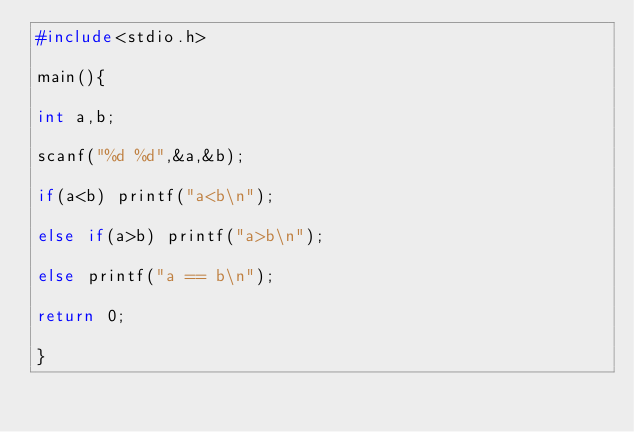<code> <loc_0><loc_0><loc_500><loc_500><_C_>#include<stdio.h>

main(){

int a,b;

scanf("%d %d",&a,&b);

if(a<b) printf("a<b\n");

else if(a>b) printf("a>b\n");

else printf("a == b\n");

return 0;

}</code> 